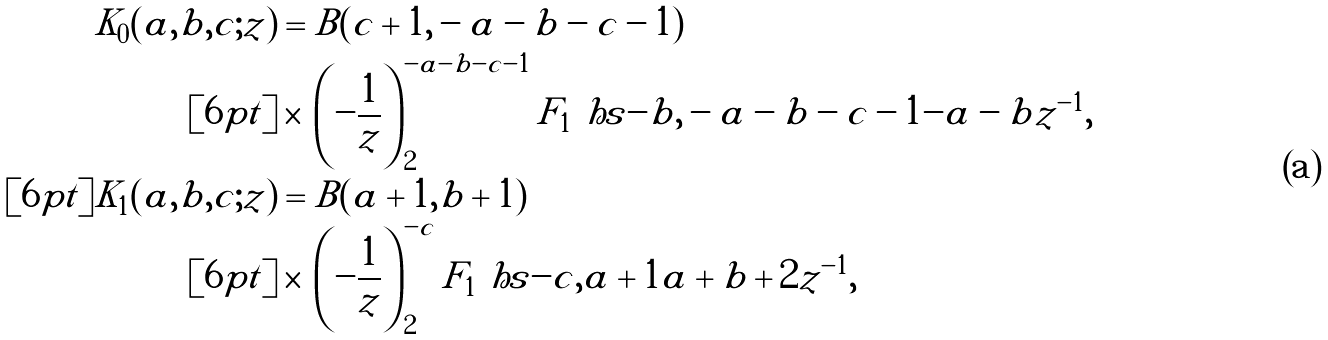<formula> <loc_0><loc_0><loc_500><loc_500>K _ { 0 } ( a , b , c ; z ) & = B ( c + 1 , - a - b - c - 1 ) \\ [ 6 p t ] & \times \, \left ( - \frac { 1 } { z } \right ) ^ { - a - b - c - 1 } _ { 2 } F _ { 1 } \ h s { - b , - a - b - c - 1 } { - a - b } { z ^ { - 1 } } , \\ [ 6 p t ] K _ { 1 } ( a , b , c ; z ) & = B ( a + 1 , b + 1 ) \\ [ 6 p t ] & \times \, \left ( - \frac { 1 } { z } \right ) ^ { - c } _ { 2 } F _ { 1 } \ h s { - c , a + 1 } { a + b + 2 } { z ^ { - 1 } } ,</formula> 